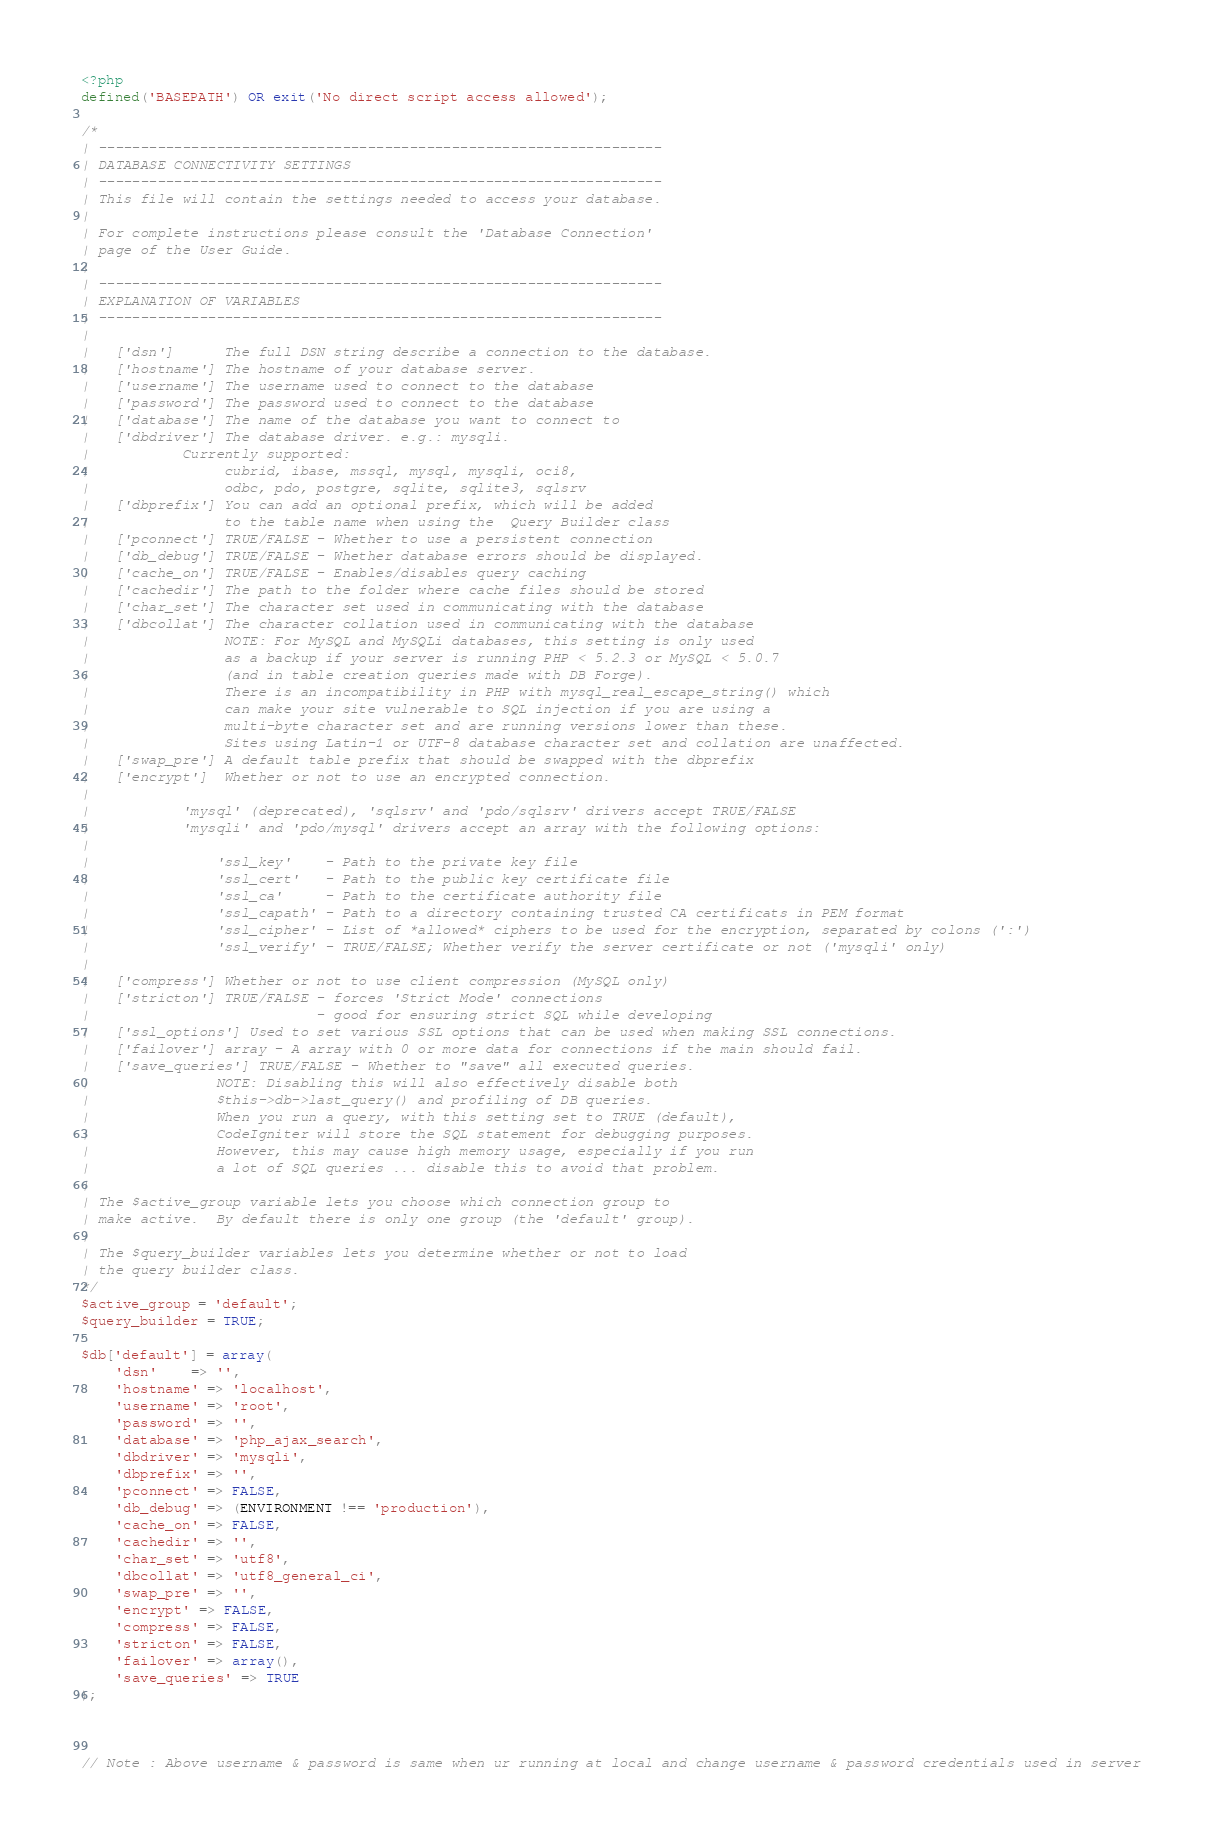Convert code to text. <code><loc_0><loc_0><loc_500><loc_500><_PHP_><?php
defined('BASEPATH') OR exit('No direct script access allowed');

/*
| -------------------------------------------------------------------
| DATABASE CONNECTIVITY SETTINGS
| -------------------------------------------------------------------
| This file will contain the settings needed to access your database.
|
| For complete instructions please consult the 'Database Connection'
| page of the User Guide.
|
| -------------------------------------------------------------------
| EXPLANATION OF VARIABLES
| -------------------------------------------------------------------
|
|	['dsn']      The full DSN string describe a connection to the database.
|	['hostname'] The hostname of your database server.
|	['username'] The username used to connect to the database
|	['password'] The password used to connect to the database
|	['database'] The name of the database you want to connect to
|	['dbdriver'] The database driver. e.g.: mysqli.
|			Currently supported:
|				 cubrid, ibase, mssql, mysql, mysqli, oci8,
|				 odbc, pdo, postgre, sqlite, sqlite3, sqlsrv
|	['dbprefix'] You can add an optional prefix, which will be added
|				 to the table name when using the  Query Builder class
|	['pconnect'] TRUE/FALSE - Whether to use a persistent connection
|	['db_debug'] TRUE/FALSE - Whether database errors should be displayed.
|	['cache_on'] TRUE/FALSE - Enables/disables query caching
|	['cachedir'] The path to the folder where cache files should be stored
|	['char_set'] The character set used in communicating with the database
|	['dbcollat'] The character collation used in communicating with the database
|				 NOTE: For MySQL and MySQLi databases, this setting is only used
| 				 as a backup if your server is running PHP < 5.2.3 or MySQL < 5.0.7
|				 (and in table creation queries made with DB Forge).
| 				 There is an incompatibility in PHP with mysql_real_escape_string() which
| 				 can make your site vulnerable to SQL injection if you are using a
| 				 multi-byte character set and are running versions lower than these.
| 				 Sites using Latin-1 or UTF-8 database character set and collation are unaffected.
|	['swap_pre'] A default table prefix that should be swapped with the dbprefix
|	['encrypt']  Whether or not to use an encrypted connection.
|
|			'mysql' (deprecated), 'sqlsrv' and 'pdo/sqlsrv' drivers accept TRUE/FALSE
|			'mysqli' and 'pdo/mysql' drivers accept an array with the following options:
|
|				'ssl_key'    - Path to the private key file
|				'ssl_cert'   - Path to the public key certificate file
|				'ssl_ca'     - Path to the certificate authority file
|				'ssl_capath' - Path to a directory containing trusted CA certificats in PEM format
|				'ssl_cipher' - List of *allowed* ciphers to be used for the encryption, separated by colons (':')
|				'ssl_verify' - TRUE/FALSE; Whether verify the server certificate or not ('mysqli' only)
|
|	['compress'] Whether or not to use client compression (MySQL only)
|	['stricton'] TRUE/FALSE - forces 'Strict Mode' connections
|							- good for ensuring strict SQL while developing
|	['ssl_options']	Used to set various SSL options that can be used when making SSL connections.
|	['failover'] array - A array with 0 or more data for connections if the main should fail.
|	['save_queries'] TRUE/FALSE - Whether to "save" all executed queries.
| 				NOTE: Disabling this will also effectively disable both
| 				$this->db->last_query() and profiling of DB queries.
| 				When you run a query, with this setting set to TRUE (default),
| 				CodeIgniter will store the SQL statement for debugging purposes.
| 				However, this may cause high memory usage, especially if you run
| 				a lot of SQL queries ... disable this to avoid that problem.
|
| The $active_group variable lets you choose which connection group to
| make active.  By default there is only one group (the 'default' group).
|
| The $query_builder variables lets you determine whether or not to load
| the query builder class.
*/
$active_group = 'default';
$query_builder = TRUE;

$db['default'] = array(
	'dsn'	=> '',
	'hostname' => 'localhost',
	'username' => 'root',
	'password' => '',
	'database' => 'php_ajax_search',
	'dbdriver' => 'mysqli',
	'dbprefix' => '',
	'pconnect' => FALSE,
	'db_debug' => (ENVIRONMENT !== 'production'),
	'cache_on' => FALSE,
	'cachedir' => '',
	'char_set' => 'utf8',
	'dbcollat' => 'utf8_general_ci',
	'swap_pre' => '',
	'encrypt' => FALSE,
	'compress' => FALSE,
	'stricton' => FALSE,
	'failover' => array(),
	'save_queries' => TRUE
);



// Note : Above username & password is same when ur running at local and change username & password credentials used in server</code> 